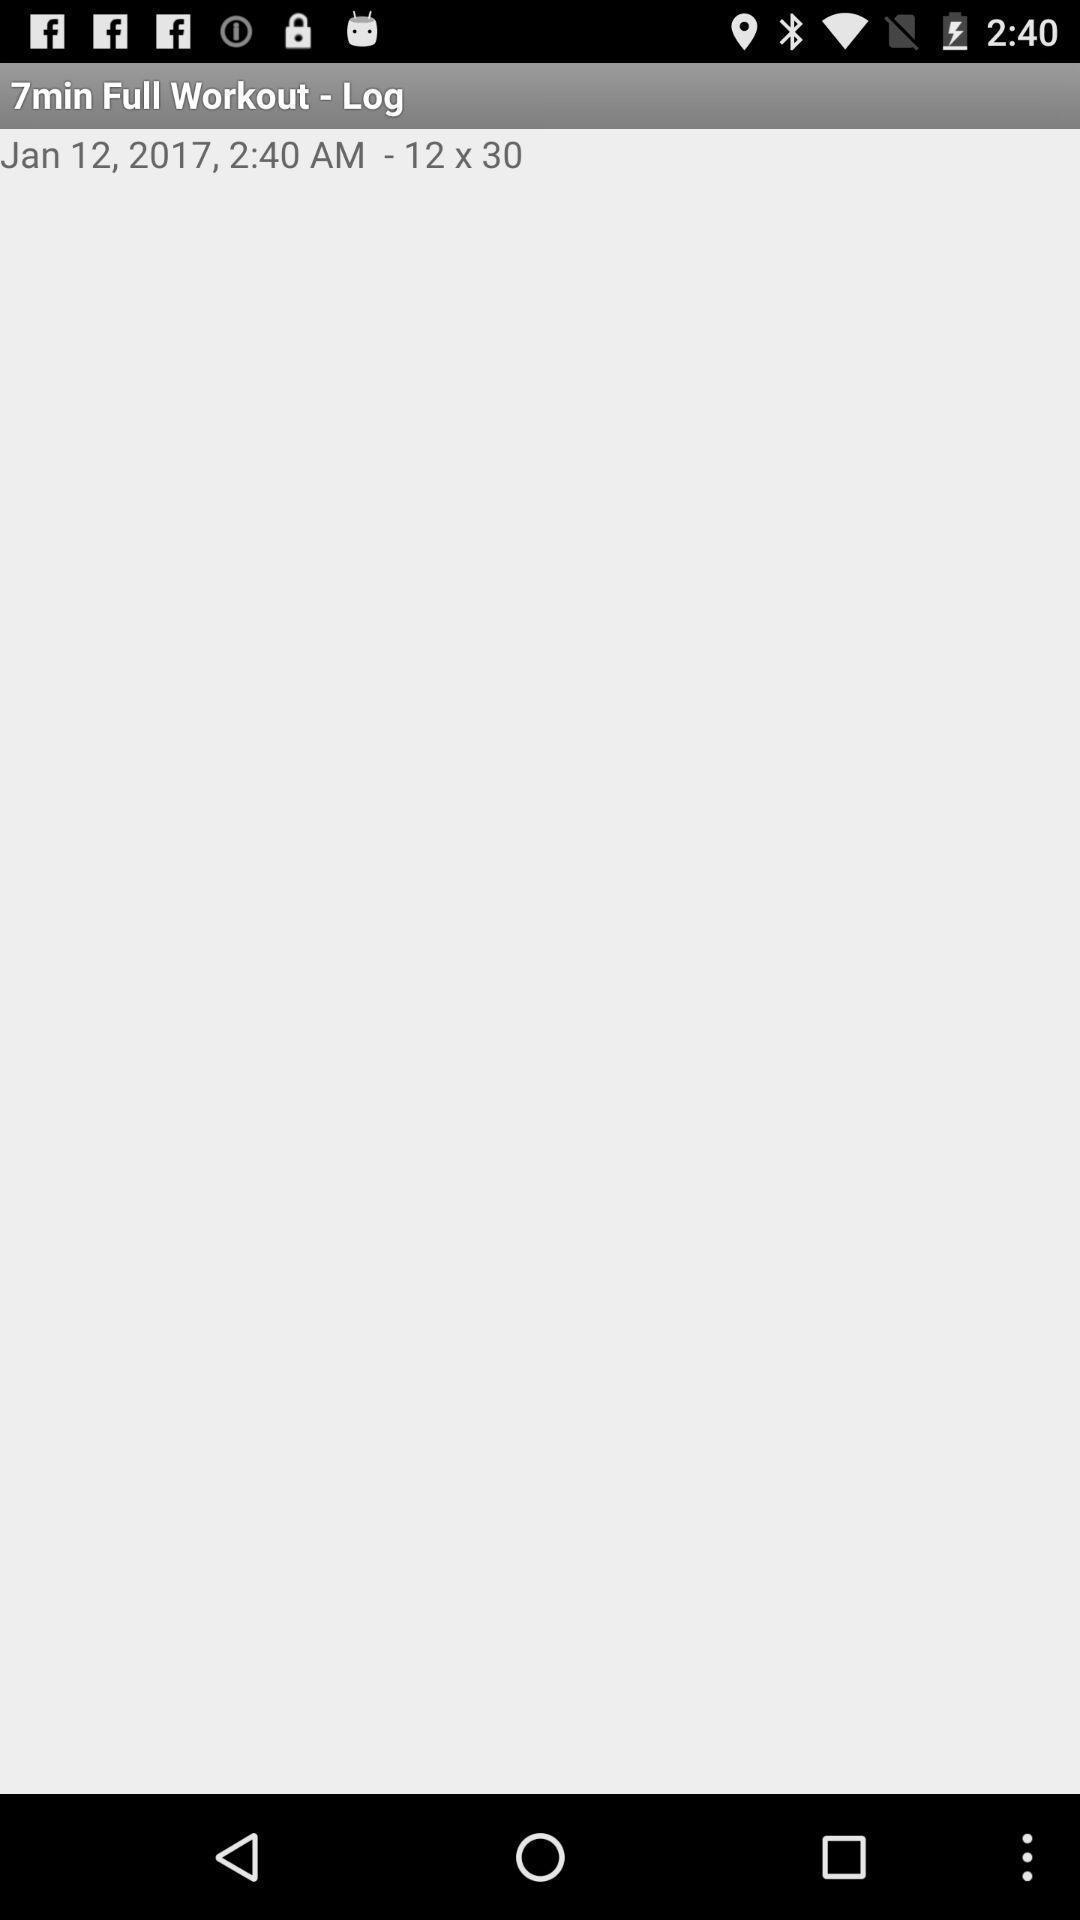What is the overall content of this screenshot? Workout details with time and date specifications. 